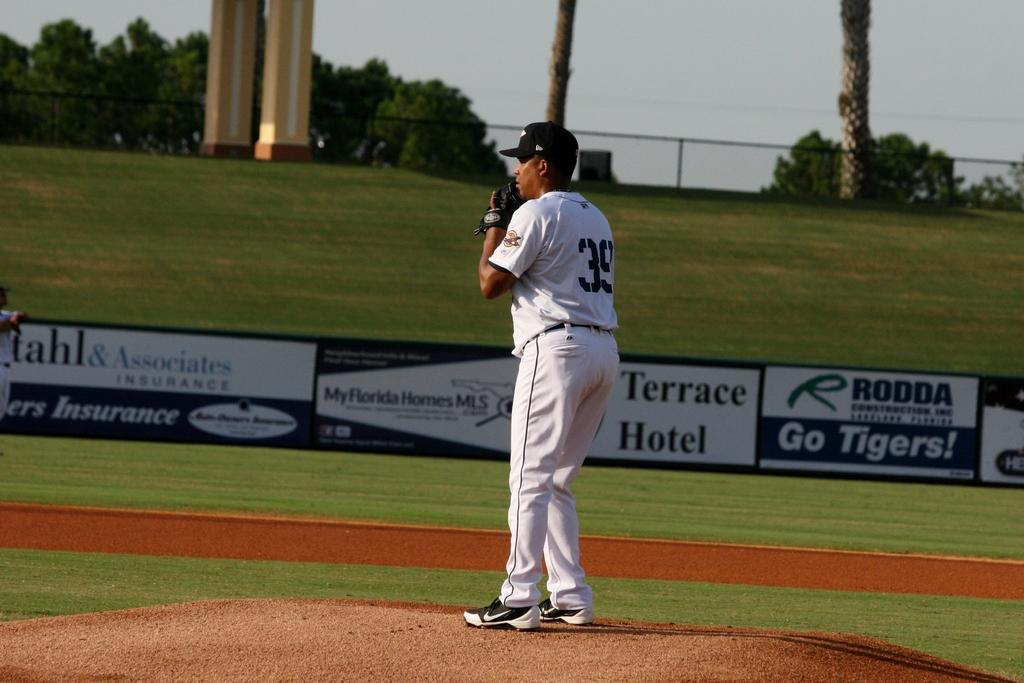<image>
Share a concise interpretation of the image provided. A pitcher on the mound of a field sponsored by the Terrace Hotel. 